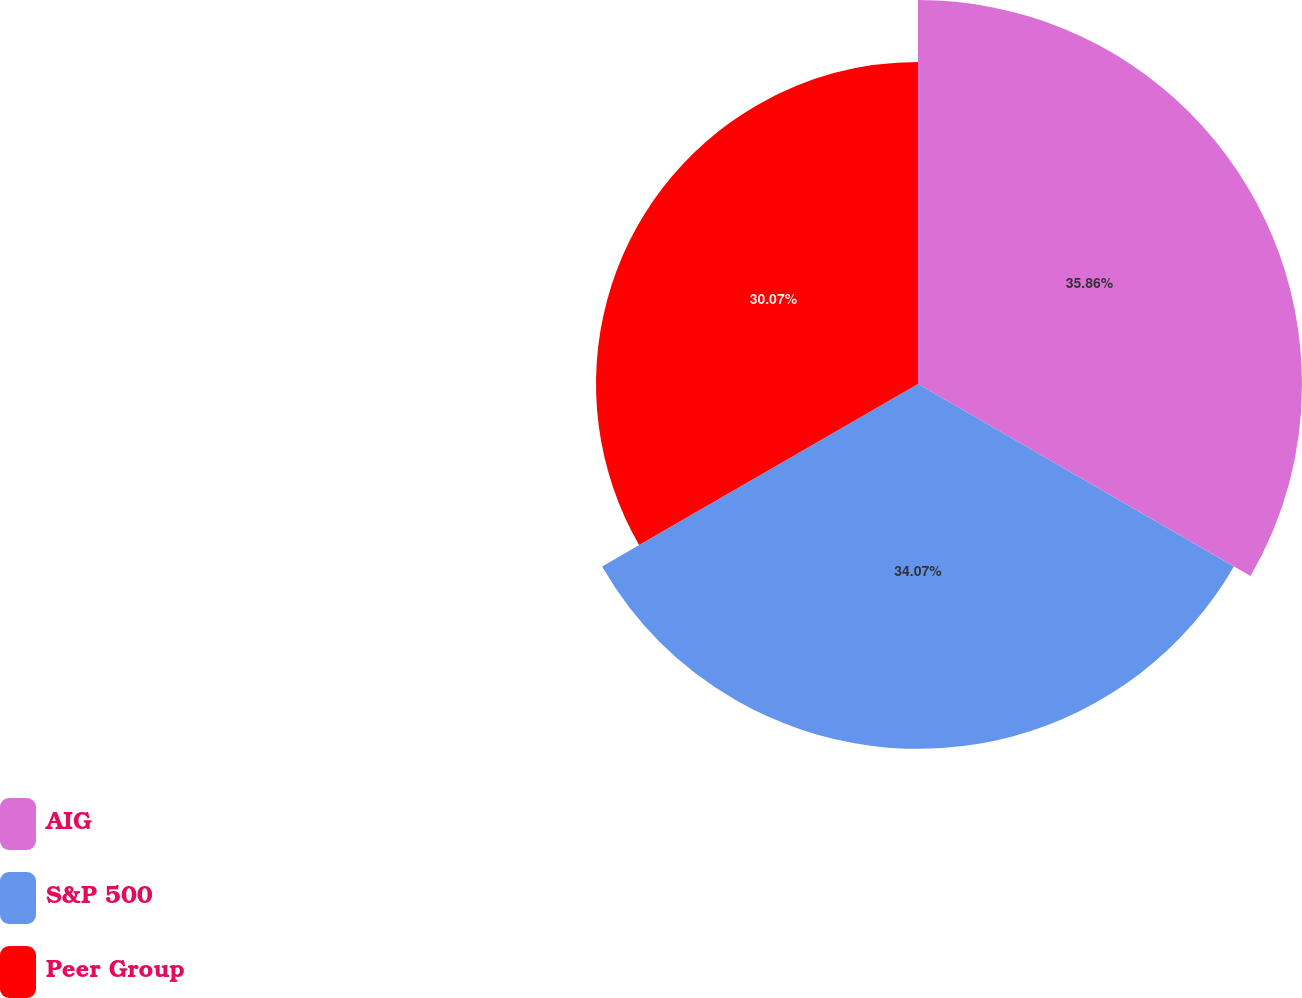Convert chart to OTSL. <chart><loc_0><loc_0><loc_500><loc_500><pie_chart><fcel>AIG<fcel>S&P 500<fcel>Peer Group<nl><fcel>35.86%<fcel>34.07%<fcel>30.07%<nl></chart> 